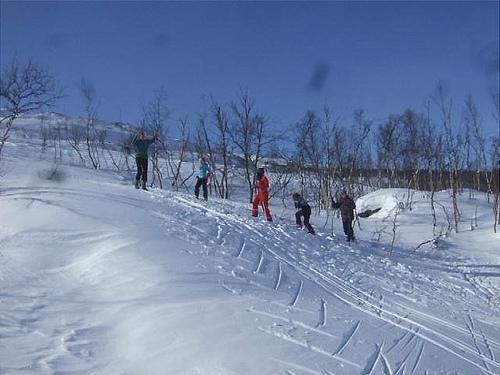How many people are visible in this photo?
Give a very brief answer. 5. 